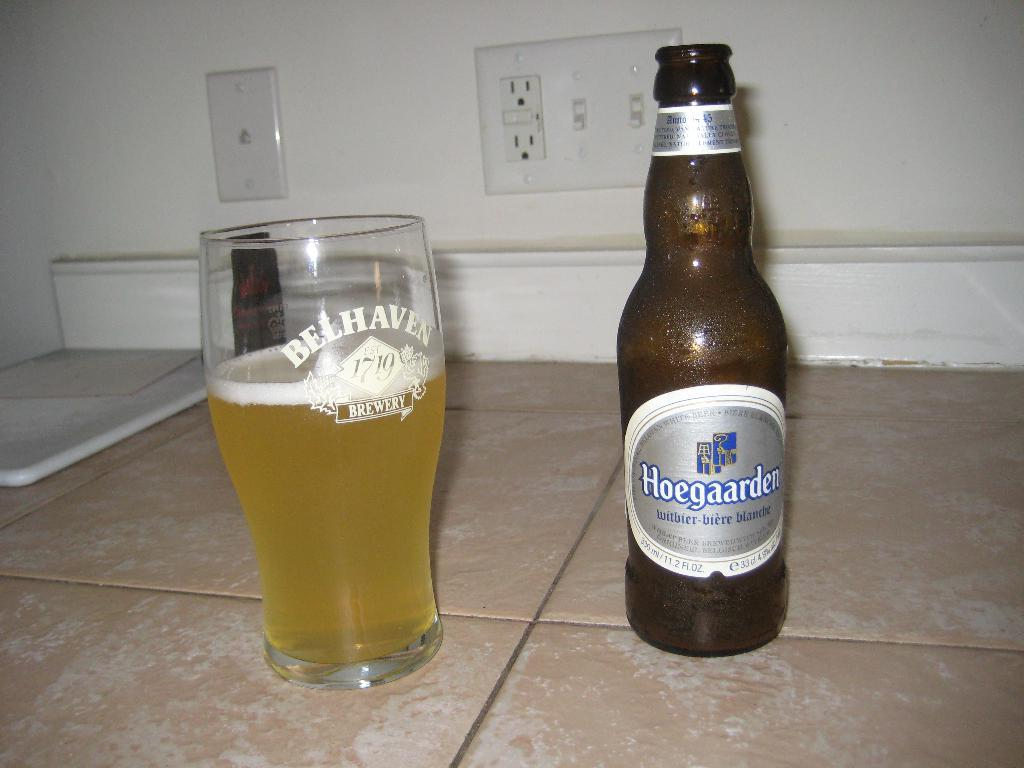<image>
Present a compact description of the photo's key features. a bottle of hoegaarden beer standing next to a glass of it 